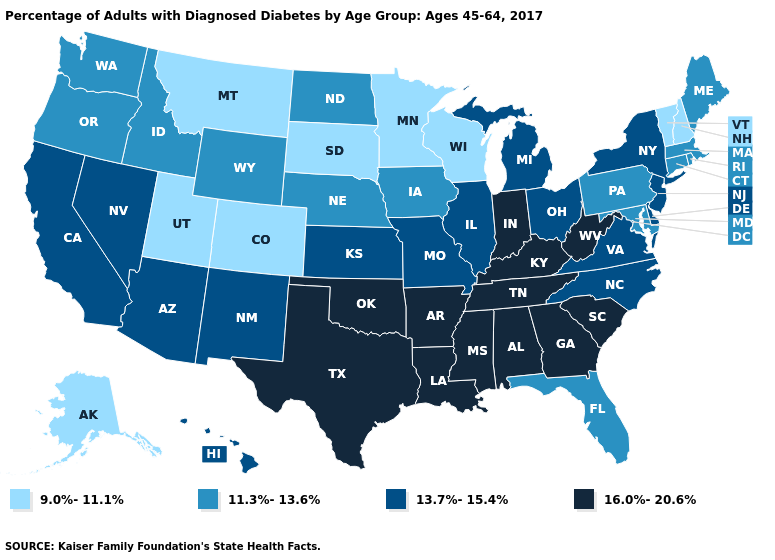What is the value of Montana?
Be succinct. 9.0%-11.1%. Name the states that have a value in the range 9.0%-11.1%?
Answer briefly. Alaska, Colorado, Minnesota, Montana, New Hampshire, South Dakota, Utah, Vermont, Wisconsin. What is the highest value in the South ?
Concise answer only. 16.0%-20.6%. Among the states that border Ohio , which have the highest value?
Short answer required. Indiana, Kentucky, West Virginia. Which states have the highest value in the USA?
Short answer required. Alabama, Arkansas, Georgia, Indiana, Kentucky, Louisiana, Mississippi, Oklahoma, South Carolina, Tennessee, Texas, West Virginia. Does Kansas have a lower value than New Hampshire?
Short answer required. No. What is the value of Mississippi?
Be succinct. 16.0%-20.6%. What is the value of California?
Short answer required. 13.7%-15.4%. Name the states that have a value in the range 11.3%-13.6%?
Answer briefly. Connecticut, Florida, Idaho, Iowa, Maine, Maryland, Massachusetts, Nebraska, North Dakota, Oregon, Pennsylvania, Rhode Island, Washington, Wyoming. Which states have the lowest value in the Northeast?
Answer briefly. New Hampshire, Vermont. Name the states that have a value in the range 13.7%-15.4%?
Quick response, please. Arizona, California, Delaware, Hawaii, Illinois, Kansas, Michigan, Missouri, Nevada, New Jersey, New Mexico, New York, North Carolina, Ohio, Virginia. What is the highest value in the USA?
Answer briefly. 16.0%-20.6%. What is the lowest value in the USA?
Quick response, please. 9.0%-11.1%. 